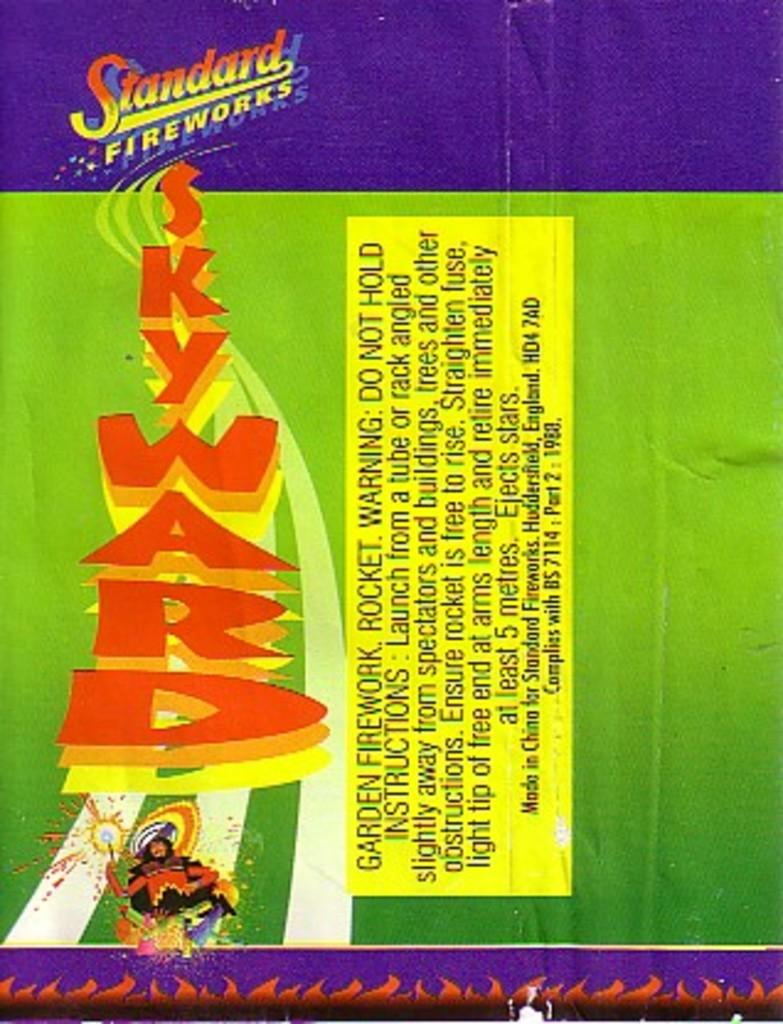<image>
Summarize the visual content of the image. Standar Fireworks label that has a cowboy on the bottom. 